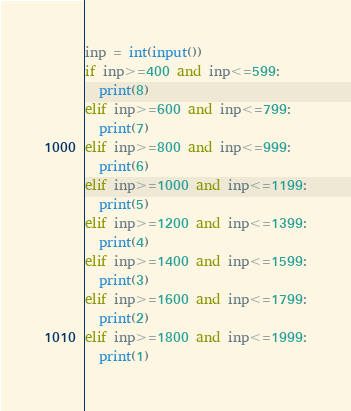Convert code to text. <code><loc_0><loc_0><loc_500><loc_500><_Python_>inp = int(input())
if inp>=400 and inp<=599:
  print(8)
elif inp>=600 and inp<=799:
  print(7)
elif inp>=800 and inp<=999:
  print(6)
elif inp>=1000 and inp<=1199:
  print(5)
elif inp>=1200 and inp<=1399:
  print(4)
elif inp>=1400 and inp<=1599:
  print(3)
elif inp>=1600 and inp<=1799:
  print(2)
elif inp>=1800 and inp<=1999:
  print(1)</code> 